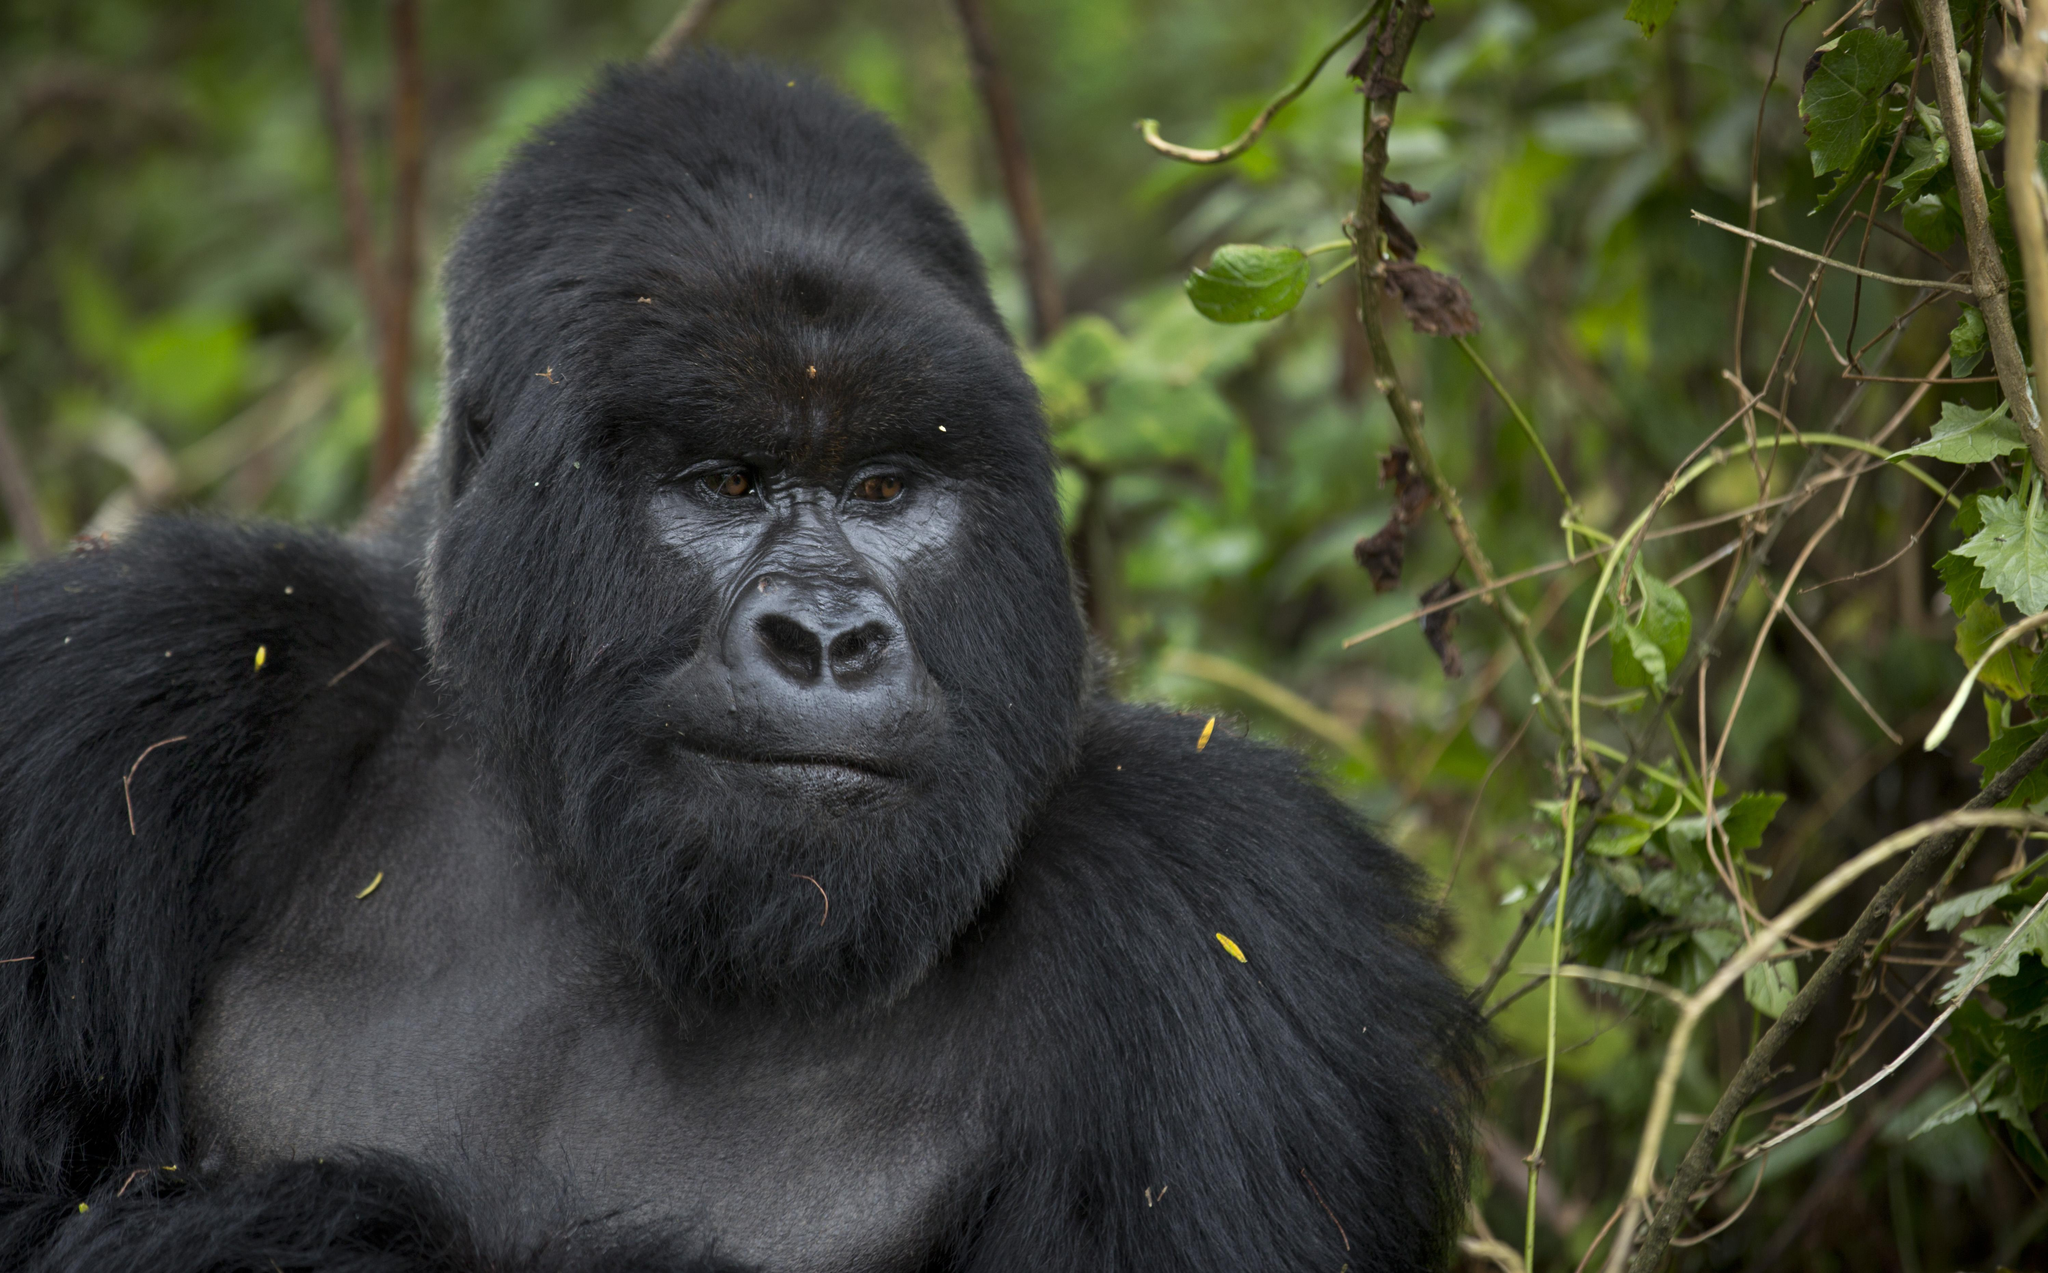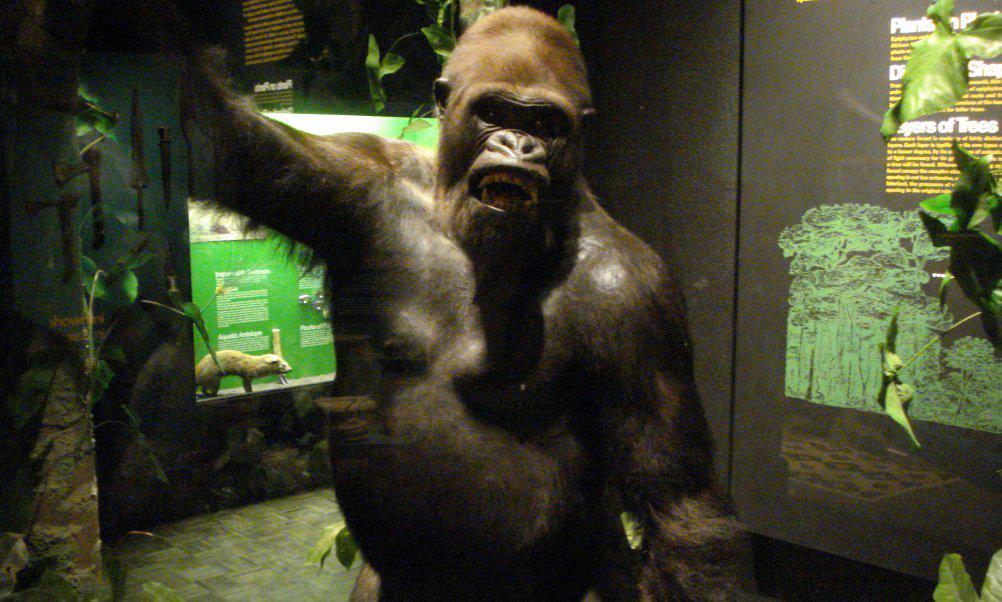The first image is the image on the left, the second image is the image on the right. Assess this claim about the two images: "There are exactly three animals.". Correct or not? Answer yes or no. No. The first image is the image on the left, the second image is the image on the right. Considering the images on both sides, is "An image shows at least one forward-facing gorilla with something stick-like in its mouth." valid? Answer yes or no. No. 